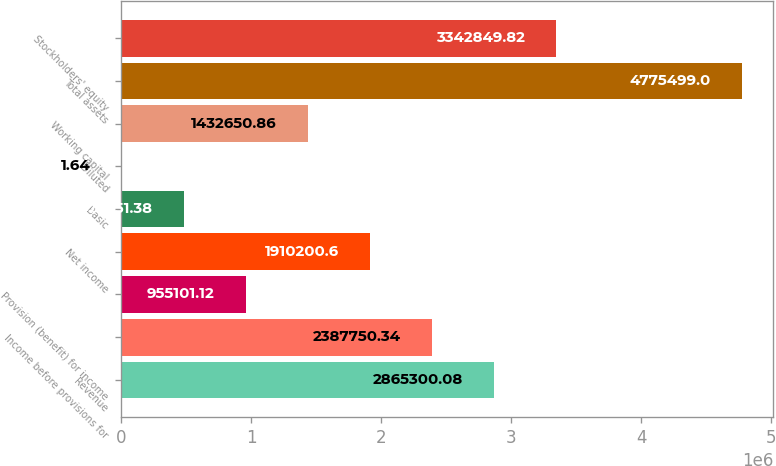<chart> <loc_0><loc_0><loc_500><loc_500><bar_chart><fcel>Revenue<fcel>Income before provisions for<fcel>Provision (benefit) for income<fcel>Net income<fcel>Basic<fcel>Diluted<fcel>Working capital<fcel>Total assets<fcel>Stockholders' equity<nl><fcel>2.8653e+06<fcel>2.38775e+06<fcel>955101<fcel>1.9102e+06<fcel>477551<fcel>1.64<fcel>1.43265e+06<fcel>4.7755e+06<fcel>3.34285e+06<nl></chart> 